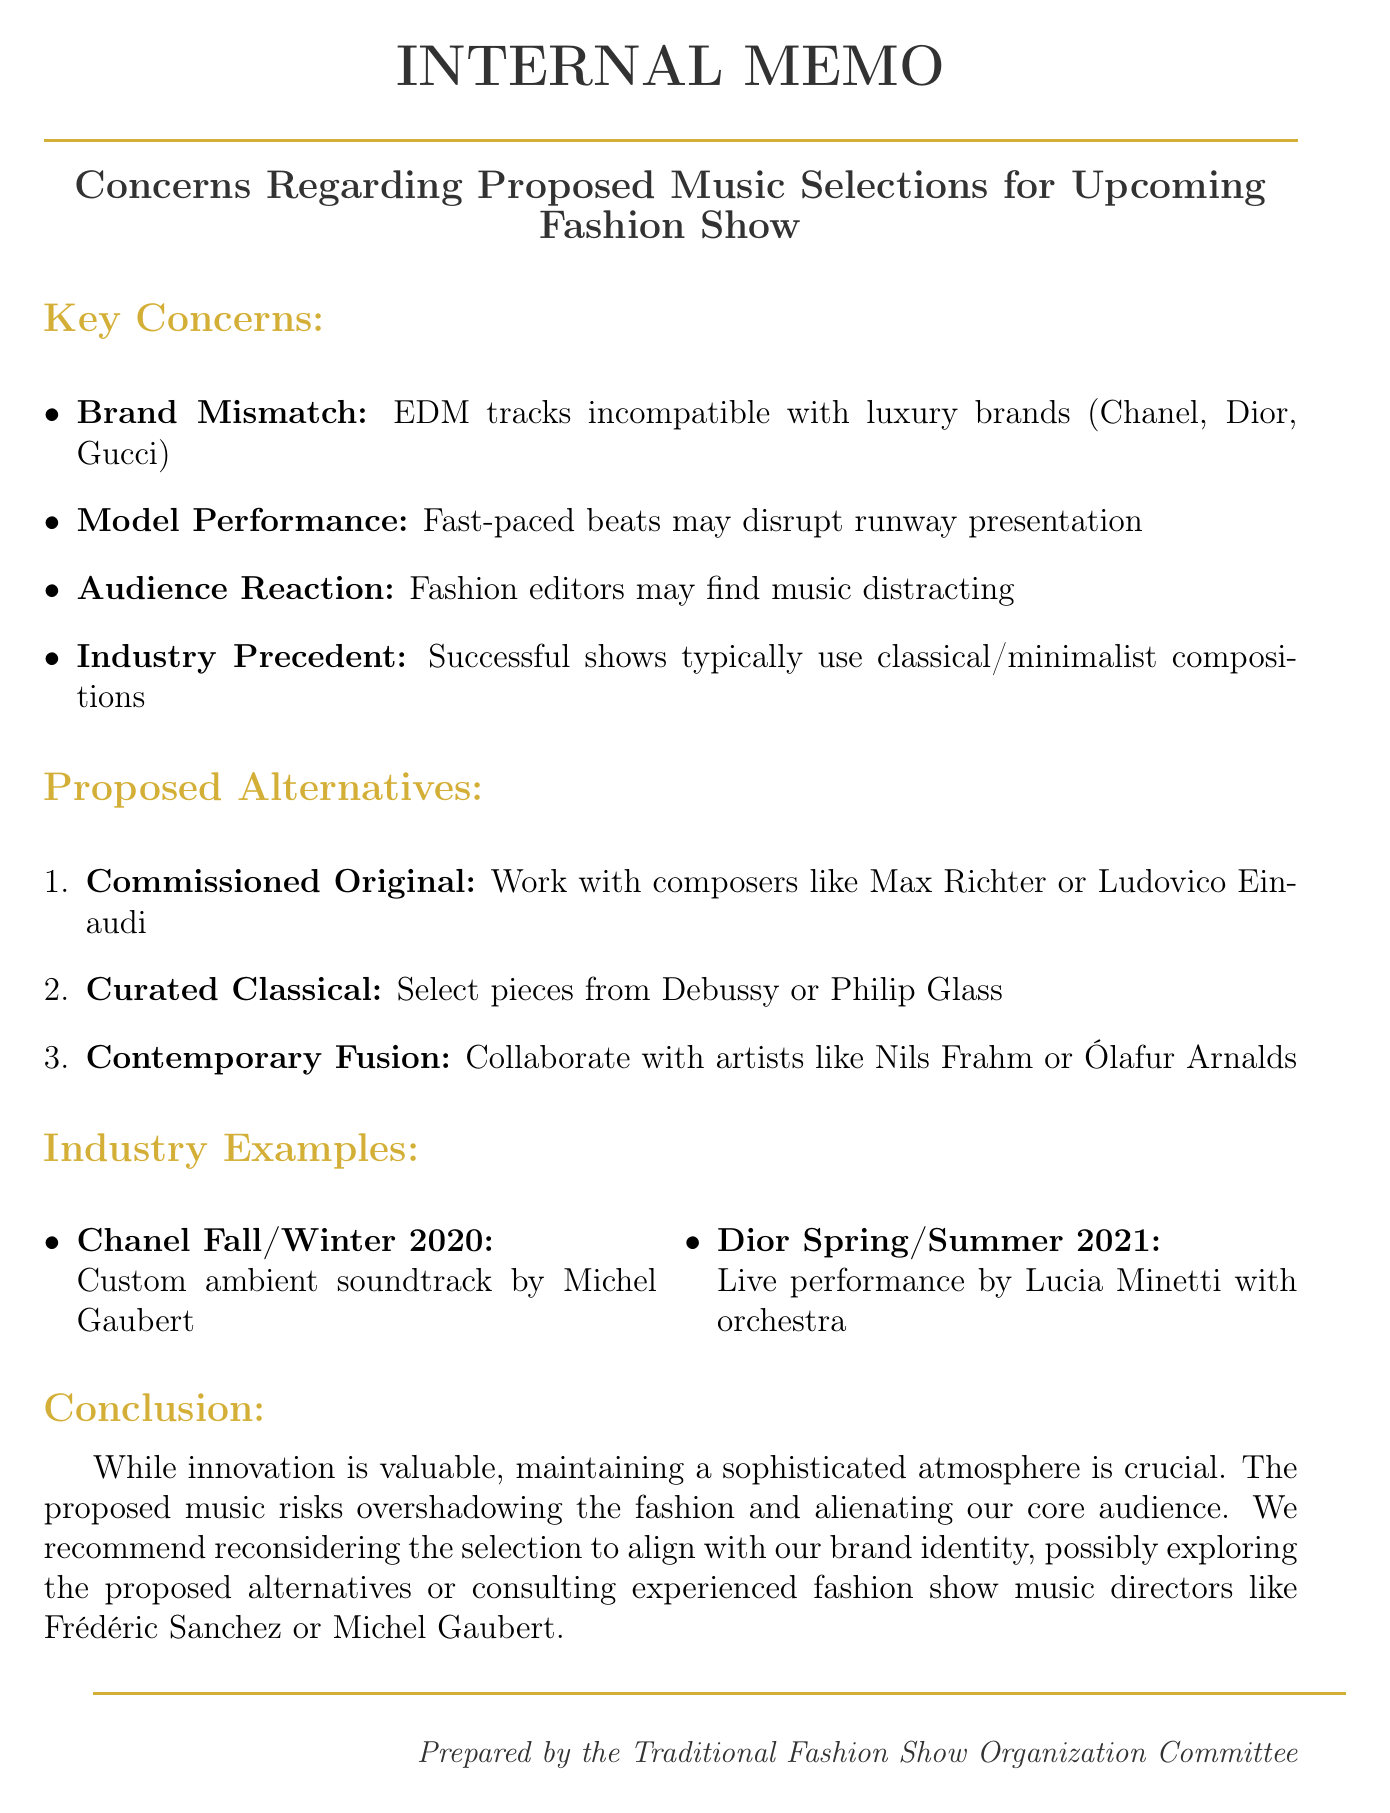What is the subject of the memo? The subject line provides a concise summary of the main topic discussed in the document.
Answer: Concerns Regarding Proposed Music Selections for Upcoming Fashion Show Which brands are mentioned as potentially mismatched with the proposed music? The key point lists specific luxury brands that may not align with the suggested music choices.
Answer: Chanel, Dior, Gucci Who are the composers proposed for a commissioned original composition? The alternative suggestions mention specific composers whose works could be utilized.
Answer: Max Richter, Ludovico Einaudi What type of music was used in the Chanel Fall/Winter 2020 Show? The industry example section specifies the type of music or performance at that particular fashion show.
Answer: Custom ambient soundtrack What is the conclusion of the memo? The conclusion summarizes the overall message regarding the importance of music selection and its impact on the show.
Answer: Maintaining a sophisticated atmosphere is crucial 